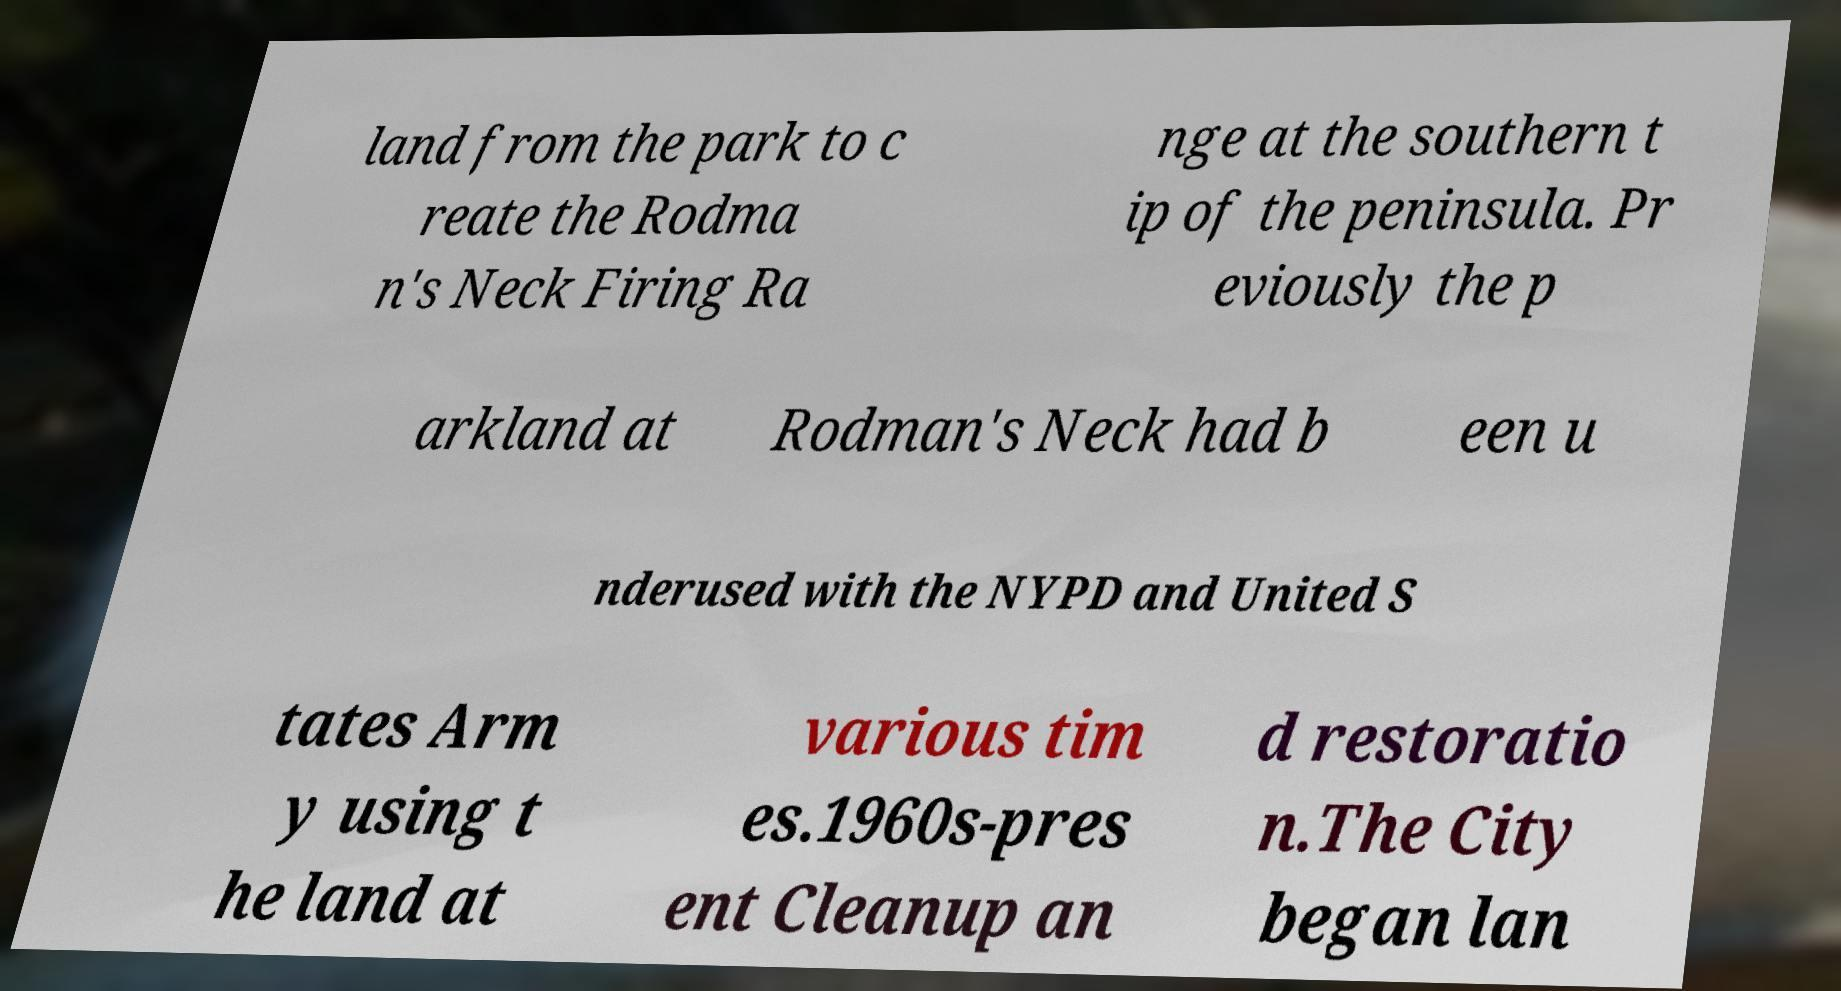For documentation purposes, I need the text within this image transcribed. Could you provide that? land from the park to c reate the Rodma n's Neck Firing Ra nge at the southern t ip of the peninsula. Pr eviously the p arkland at Rodman's Neck had b een u nderused with the NYPD and United S tates Arm y using t he land at various tim es.1960s-pres ent Cleanup an d restoratio n.The City began lan 